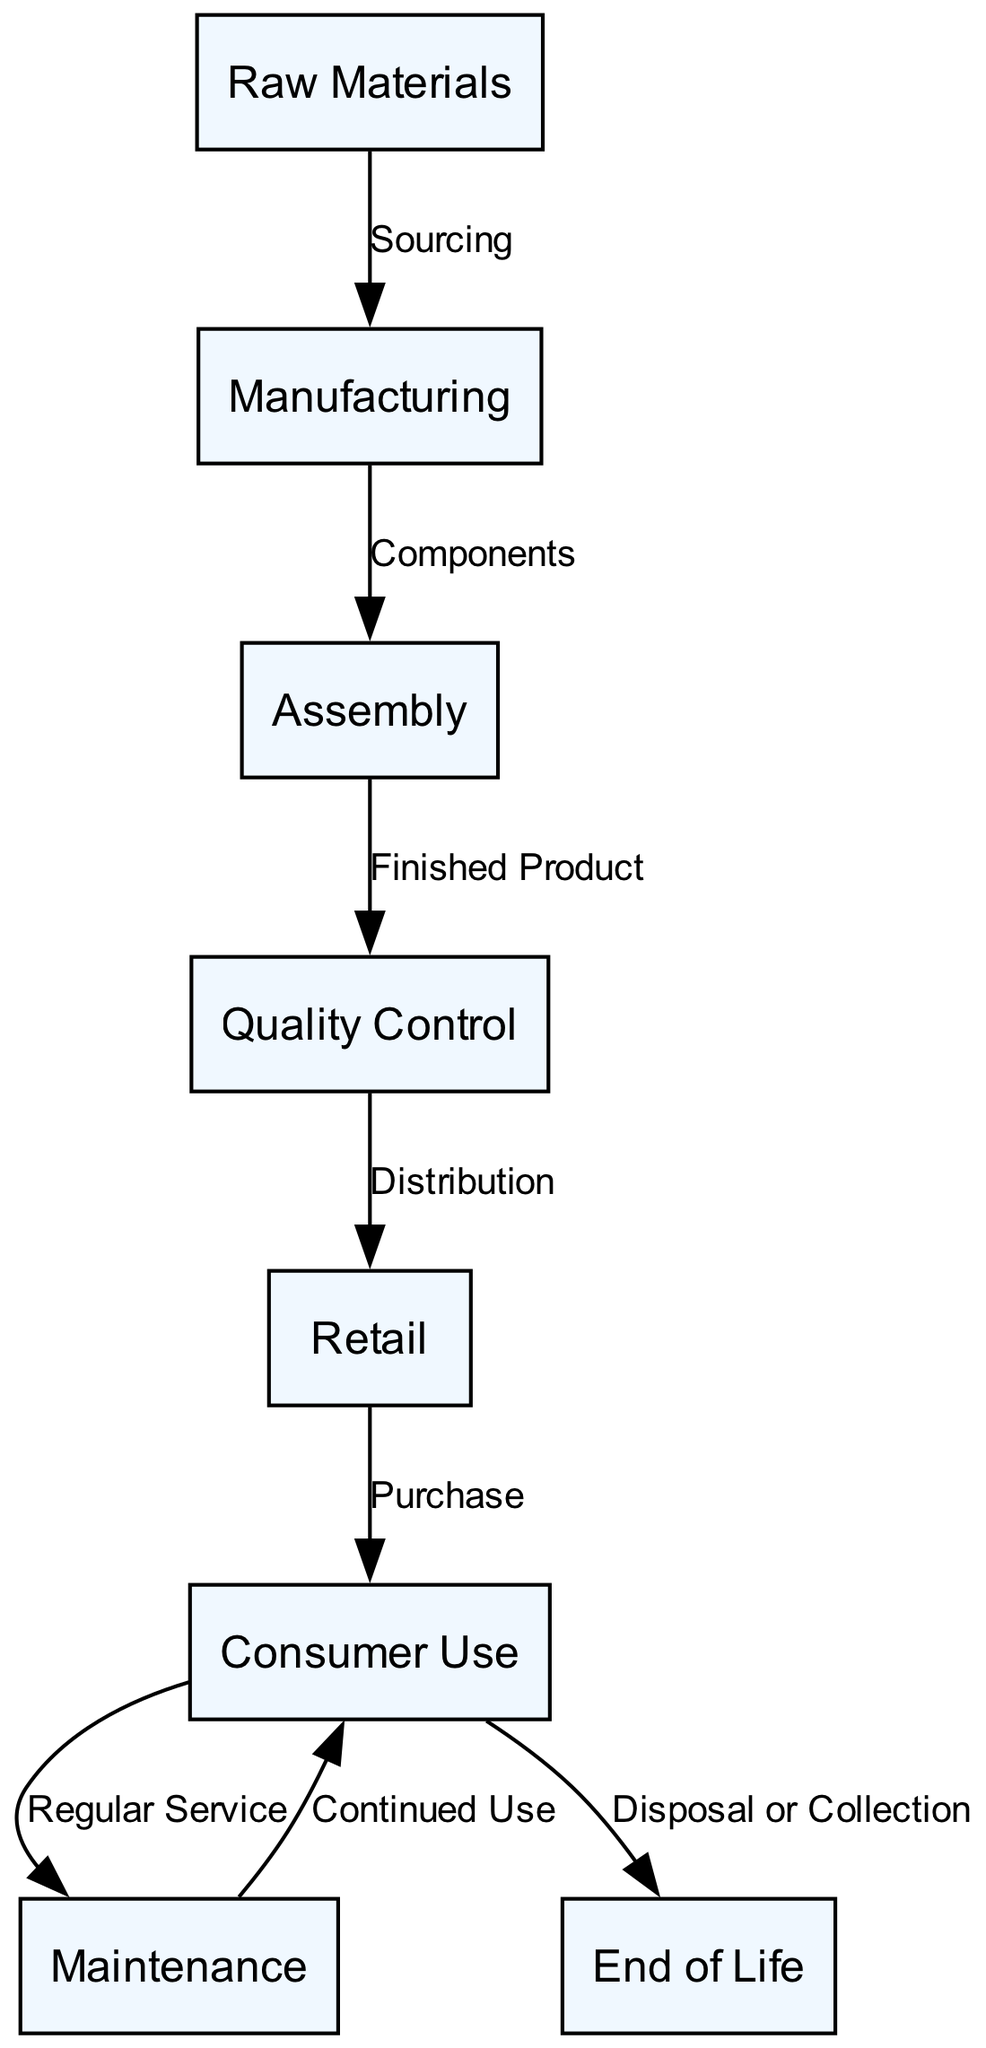What is the first step in the lifecycle of a traditional wristwatch? The diagram indicates that the first step in the lifecycle is "Raw Materials". This is represented as the initial node connected to subsequent steps.
Answer: Raw Materials How many total nodes are in the diagram? By counting the nodes represented in the diagram, we see there are 8 distinct nodes.
Answer: 8 What connects "Consumer Use" to "Maintenance"? The arrow labeled "Regular Service" shows the connection from "Consumer Use" to "Maintenance". It indicates that maintenance is carried out regularly during the consumer use phase.
Answer: Regular Service What is the last step in the lifecycle of a traditional wristwatch? The last step indicated in the diagram is "End of Life". This is where the lifecycle concludes after consumer use.
Answer: End of Life Which node represents the process of verifying quality? The node labeled "Quality Control" represents the process of verifying the quality of the wristwatch after it has been manufactured and assembled.
Answer: Quality Control How does the manufacturing process connect to assembly? The connection is depicted as "Components", indicating that manufacturing produces components necessary for assembly.
Answer: Components What is the relationship between "Retail" and "Consumer Use"? The relationship between "Retail" and "Consumer Use" is labeled as "Purchase", indicating that consumers buy watches at retail.
Answer: Purchase What process leads to the disposal or collection of the wristwatch? The process that leads to the disposal or collection is labeled "Disposal or Collection", indicating the end of the lifecycle of the watch.
Answer: Disposal or Collection Which two steps are directly connected after the "Quality Control"? The steps directly connected after "Quality Control" are "Retail" and "Consumer Use", showing the flow from verifying quality to distribution and then to consumer purchase.
Answer: Retail, Consumer Use 